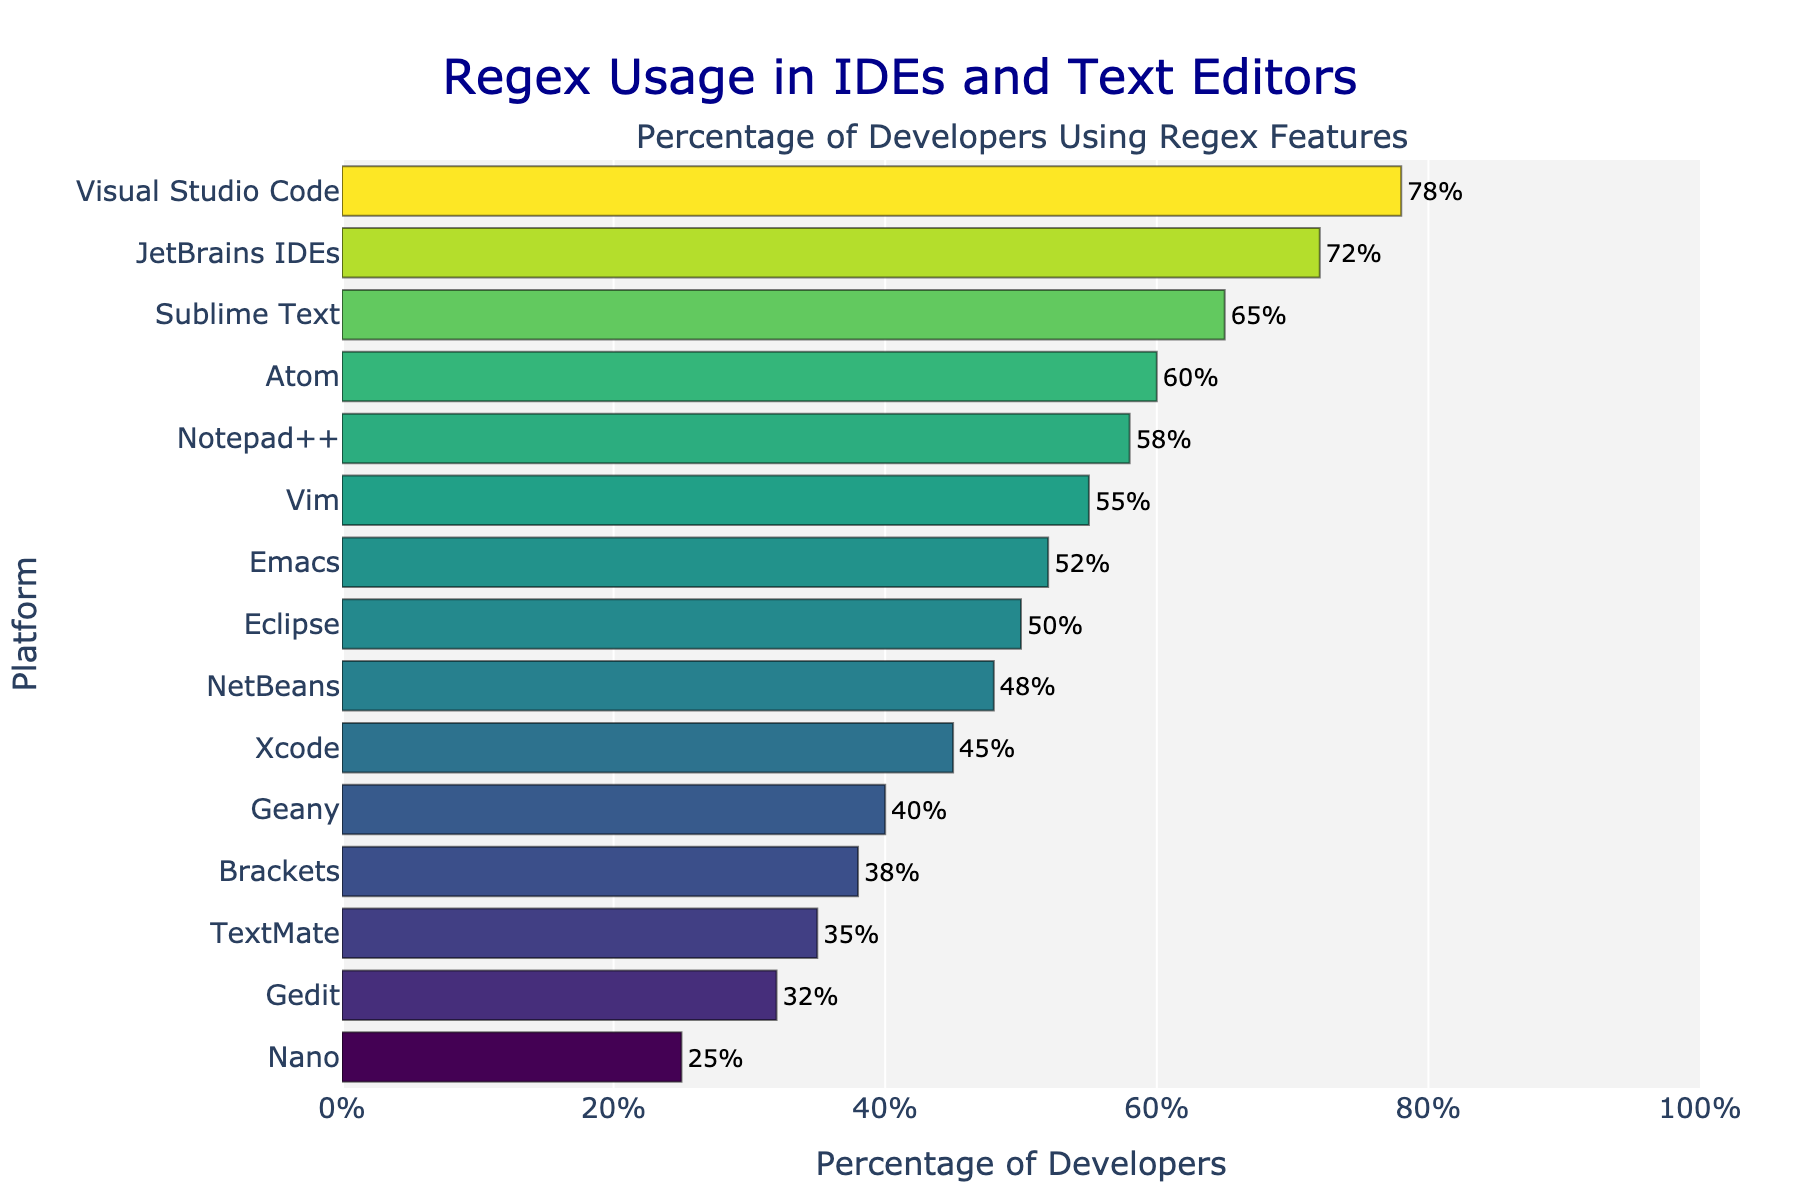Which platform shows the highest percentage of developers using regex features? The top bar on the chart, labeled "Visual Studio Code", extends furthest to the right, indicating the highest percentage.
Answer: Visual Studio Code Among Sublime Text, Atom, and Notepad++, which platform has the lowest usage percentage of regex features? Comparing the lengths of the bars for Sublime Text (65%), Atom (60%), and Notepad++ (58%), the bar for Notepad++ is the shortest, indicating the lowest percentage.
Answer: Notepad++ What is the difference in percentage points between JetBrains IDEs and Vim? The percentage for JetBrains IDEs is 72%, and for Vim, it is 55%. Subtracting these gives 72% - 55% = 17%.
Answer: 17% How many platforms have a percentage greater than or equal to 60%? The platforms with percentages ≥ 60% are Visual Studio Code (78%), JetBrains IDEs (72%), Sublime Text (65%), and Atom (60%). Counting these, there are 4 platforms.
Answer: 4 Which has a higher usage of regex features, Eclipse or Emacs? Comparing the bars for Eclipse (50%) and Emacs (52%), the bar for Emacs extends slightly further, indicating a higher percentage.
Answer: Emacs What is the average percentage of regex usage for Visual Studio Code, JetBrains IDEs, and Eclipse? Adding the percentages for Visual Studio Code (78%), JetBrains IDEs (72%), and Eclipse (50%) gives 200%. Dividing by 3, the average is approximately 66.67%.
Answer: 66.67% What is the combined percentage of regex usage for the three platforms with the lowest percentages? The three platforms with the lowest percentages are Nano (25%), Gedit (32%), and TextMate (35%). Summing these gives 25% + 32% + 35% = 92%.
Answer: 92% Is the percentage of developers using regex features in Atom greater than that of Vim and Emacs combined? Atom's percentage is 60%. Vim (55%) and Emacs (52%) combined give 55% + 52% = 107%. Since 60% is less than 107%, Atom's usage is not greater.
Answer: No Which platform's bar is closest in length to Xcode's bar? Xcode has a percentage of 45%, and the platform with a similar percentage is NetBeans at 48%, making their bars close in length.
Answer: NetBeans What is the percentage difference between the highest and lowest platforms in regex usage? The highest platform, Visual Studio Code, is at 78%, and the lowest, Nano, is at 25%. The difference is 78% - 25% = 53%.
Answer: 53% 